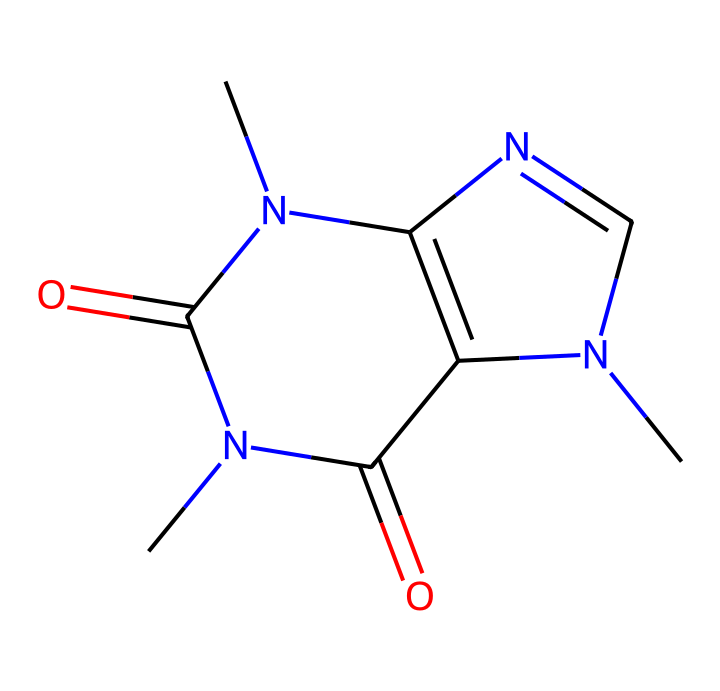What is the molecular formula of caffeine? To determine the molecular formula, we can count the number of each type of atom in the structure: Carbon (C), Hydrogen (H), Nitrogen (N), and Oxygen (O). The structure has 8 Carbon atoms, 10 Hydrogen atoms, 4 Nitrogen atoms, and 2 Oxygen atoms. Therefore, the molecular formula is C8H10N4O2.
Answer: C8H10N4O2 How many nitrogen atoms are present in caffeine? By examining the structure, we can see that there are four distinct nitrogen atoms (N) in the caffeine molecule, represented in the SMILES notation as "N" occurrences.
Answer: 4 What type of chemical is caffeine classified as? Caffeine contains several nitrogen atoms and exhibits a structure characteristic of alkaloids, which are a group of naturally occurring compounds often with pharmacological effects. This classification is based on its structure and properties.
Answer: alkaloid What functional groups are present in caffeine? By breaking down the structure, we can identify the functional groups. Caffeine contains carbonyl groups (C=O) and amine groups (N-H). The C=O represents a ketone or amide functional group, indicating it has both amine and carbonyl characteristics.
Answer: carbonyl and amine What is the number of rings present in the caffeine structure? By analyzing the structure, we identify two fused aromatic rings in caffeine. Since there are two cyclic structures combined, we conclude that caffeine has two rings.
Answer: 2 What property does caffeine have due to the presence of nitrogen? The presence of nitrogen atoms contributes to the basicity of the molecule, since nitrogen can donate a pair of electrons in reactions. This makes caffeine a basic compound in chemical terms.
Answer: basicity 